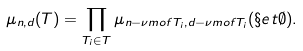<formula> <loc_0><loc_0><loc_500><loc_500>\mu _ { n , d } ( T ) = \prod _ { T _ { i } \in T } \mu _ { n - \nu m o f { T _ { i } } , d - \nu m o f { T _ { i } } } ( \S e t { \emptyset } ) .</formula> 